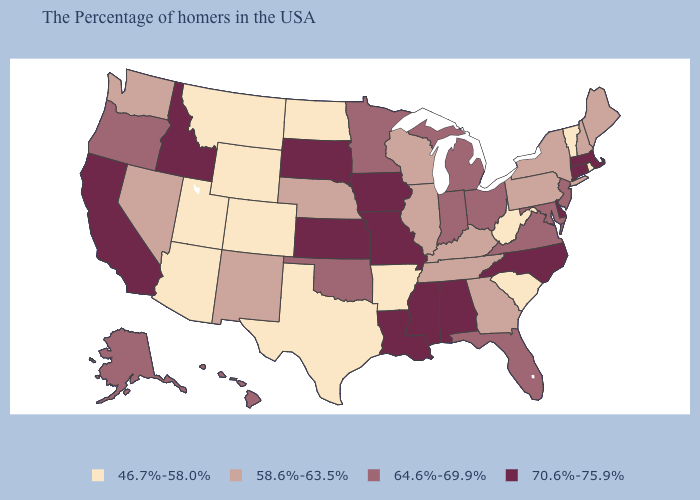Is the legend a continuous bar?
Write a very short answer. No. Does Delaware have a lower value than Indiana?
Be succinct. No. Which states have the lowest value in the USA?
Short answer required. Rhode Island, Vermont, South Carolina, West Virginia, Arkansas, Texas, North Dakota, Wyoming, Colorado, Utah, Montana, Arizona. Does the map have missing data?
Give a very brief answer. No. What is the value of Nebraska?
Give a very brief answer. 58.6%-63.5%. Does the map have missing data?
Concise answer only. No. Does Connecticut have the highest value in the USA?
Give a very brief answer. Yes. What is the value of Wyoming?
Write a very short answer. 46.7%-58.0%. What is the lowest value in the USA?
Answer briefly. 46.7%-58.0%. Which states have the lowest value in the MidWest?
Give a very brief answer. North Dakota. Is the legend a continuous bar?
Answer briefly. No. What is the value of Alaska?
Keep it brief. 64.6%-69.9%. What is the value of Wisconsin?
Answer briefly. 58.6%-63.5%. Name the states that have a value in the range 58.6%-63.5%?
Be succinct. Maine, New Hampshire, New York, Pennsylvania, Georgia, Kentucky, Tennessee, Wisconsin, Illinois, Nebraska, New Mexico, Nevada, Washington. What is the lowest value in the MidWest?
Short answer required. 46.7%-58.0%. 